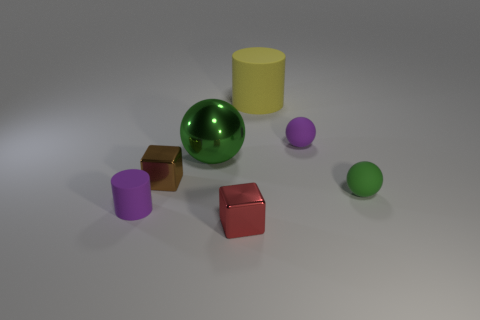Add 2 tiny matte cylinders. How many objects exist? 9 Subtract all purple spheres. How many spheres are left? 2 Subtract all matte balls. How many balls are left? 1 Subtract 0 cyan cylinders. How many objects are left? 7 Subtract all cubes. How many objects are left? 5 Subtract 2 cylinders. How many cylinders are left? 0 Subtract all purple cylinders. Subtract all red cubes. How many cylinders are left? 1 Subtract all purple blocks. How many cyan cylinders are left? 0 Subtract all large green things. Subtract all tiny brown cubes. How many objects are left? 5 Add 4 tiny purple cylinders. How many tiny purple cylinders are left? 5 